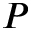<formula> <loc_0><loc_0><loc_500><loc_500>P</formula> 